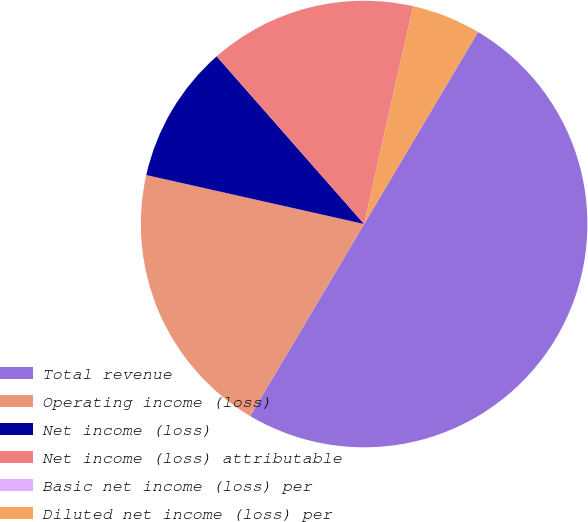Convert chart. <chart><loc_0><loc_0><loc_500><loc_500><pie_chart><fcel>Total revenue<fcel>Operating income (loss)<fcel>Net income (loss)<fcel>Net income (loss) attributable<fcel>Basic net income (loss) per<fcel>Diluted net income (loss) per<nl><fcel>50.0%<fcel>20.0%<fcel>10.0%<fcel>15.0%<fcel>0.0%<fcel>5.0%<nl></chart> 